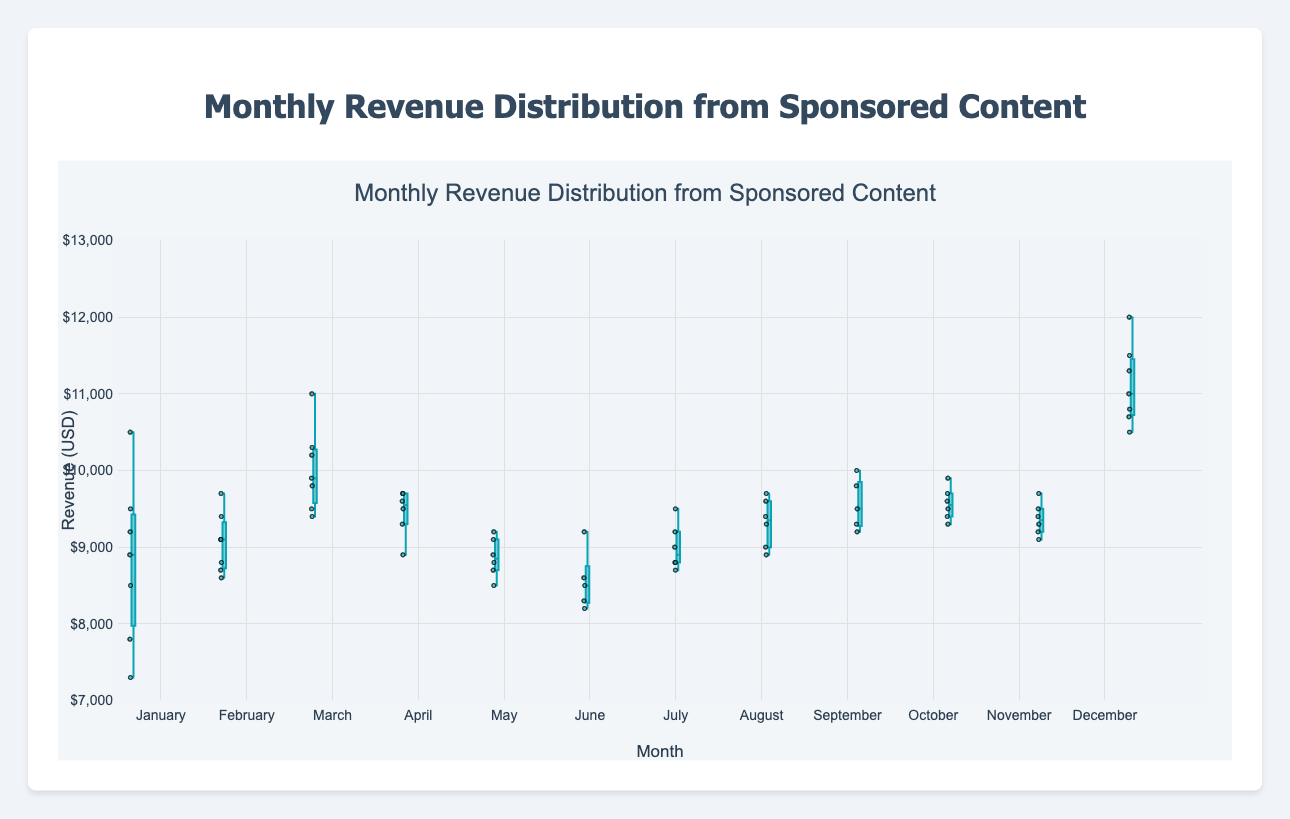What's the range of revenue in January? The range of a box plot is determined by subtracting the minimum value from the maximum value. For January, the smallest value is 7300 and the largest value is 10500. Thus, the range is 10500 - 7300 = 3200.
Answer: 3200 What's the median revenue for March? The median value is the middle value when the data points are sorted in ascending order. For March, the sorted values are [9400, 9500, 9800, 9900, 10200, 10300, 11000]. The median is the fourth value, which is 9900.
Answer: 9900 Which month has the highest median revenue? By comparing the median lines of the box plots for each month, December has the highest median revenue.
Answer: December How does the distribution of revenue in June compare to that in December? June shows a narrower spread with revenue values ranging between 8200 and 9200, whereas December shows a wider spread with revenue values ranging from 10500 to 12000. Additionally, December's median revenue is much higher.
Answer: December has a higher and wider distribution What's the interquartile range (IQR) for October? The interquartile range is the difference between the third quartile (Q3) and the first quartile (Q1). For October, Q3 is approximately 9700 and Q1 is about 9400. The IQR is 9700 - 9400 = 300.
Answer: 300 Which month has the lowest minimum revenue value? By looking at the lower whiskers of the box plots, January has the lowest minimum revenue value of 7300.
Answer: January How many months have a median revenue greater than 10000? By checking the median lines in the box plots, there is only one month with a median revenue greater than 10000, which is December.
Answer: 1 What is the difference between the maximum revenue in July and August? The maximum revenue in July is 9500 and for August is 9700. The difference is 9700 - 9500 = 200.
Answer: 200 Is there any month that has an outlier below 8000? By scanning the points outside the whiskers in the box plots, January has an outlier that falls below 8000 (specifically 7300).
Answer: Yes, January 